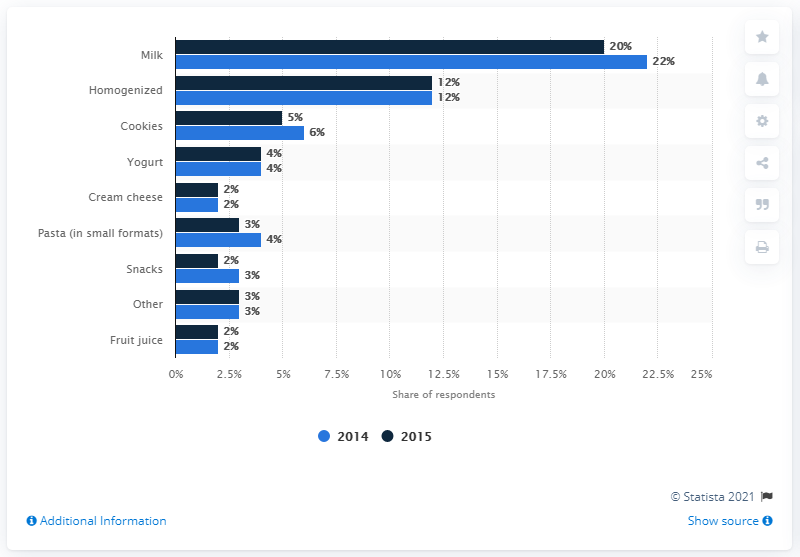Identify some key points in this picture. In 2015, milk accounted for approximately 60% of Italian baby food spending. 